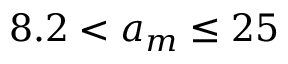<formula> <loc_0><loc_0><loc_500><loc_500>8 . 2 < a _ { m } \leq 2 5</formula> 